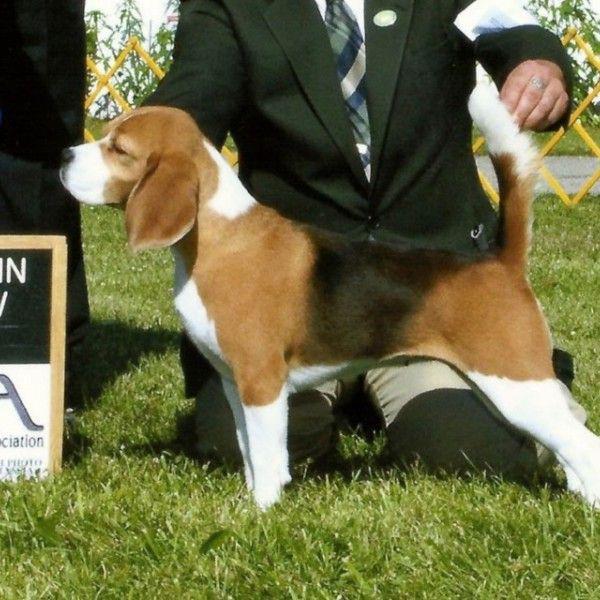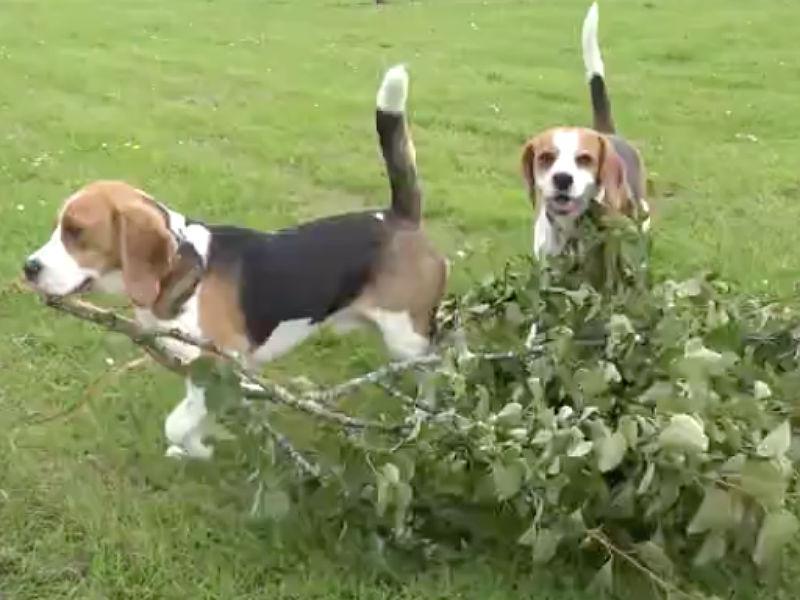The first image is the image on the left, the second image is the image on the right. Considering the images on both sides, is "Flowers of some type are behind a dog in at least one image, and at least one image includes a beagle puppy." valid? Answer yes or no. No. The first image is the image on the left, the second image is the image on the right. For the images displayed, is the sentence "There are two dogs in the right image." factually correct? Answer yes or no. Yes. 